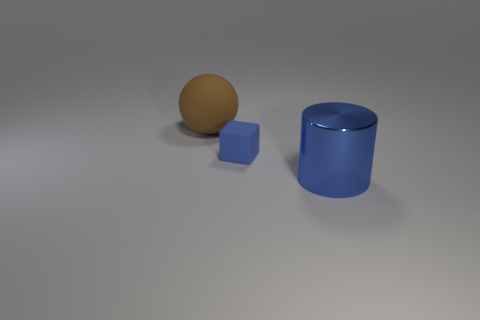How big is the blue thing behind the blue metallic object that is on the right side of the matte object that is in front of the large matte ball?
Offer a terse response. Small. There is a blue matte thing; are there any large cylinders left of it?
Keep it short and to the point. No. There is a blue thing that is the same material as the brown sphere; what size is it?
Provide a short and direct response. Small. What number of blue matte objects are the same shape as the large brown rubber thing?
Give a very brief answer. 0. Does the small blue object have the same material as the large object behind the tiny blue rubber thing?
Your answer should be very brief. Yes. Is the number of large blue metal cylinders on the right side of the large shiny object greater than the number of large blue cylinders?
Provide a short and direct response. No. There is a thing that is the same color as the big metallic cylinder; what shape is it?
Offer a very short reply. Cube. Are there any objects made of the same material as the large brown sphere?
Provide a succinct answer. Yes. Do the blue object that is to the left of the big shiny cylinder and the object on the right side of the small object have the same material?
Provide a short and direct response. No. Are there an equal number of things in front of the large rubber object and large metal cylinders on the right side of the blue metallic cylinder?
Provide a succinct answer. No. 